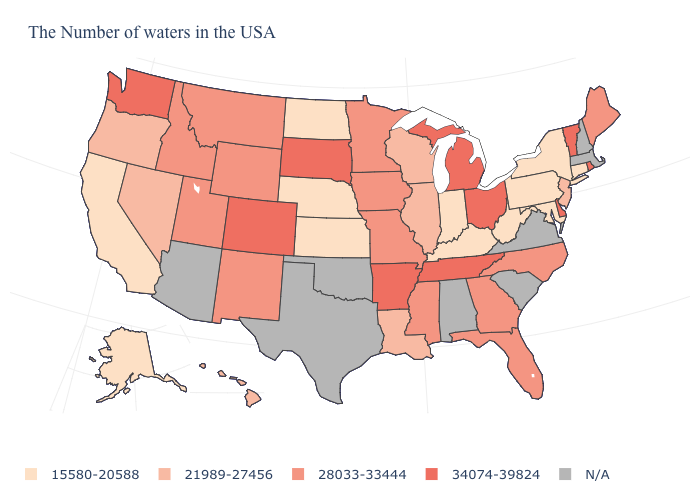Which states have the lowest value in the USA?
Write a very short answer. Connecticut, New York, Maryland, Pennsylvania, West Virginia, Kentucky, Indiana, Kansas, Nebraska, North Dakota, California, Alaska. Name the states that have a value in the range N/A?
Keep it brief. Massachusetts, New Hampshire, Virginia, South Carolina, Alabama, Oklahoma, Texas, Arizona. What is the value of Wyoming?
Concise answer only. 28033-33444. What is the value of Rhode Island?
Write a very short answer. 34074-39824. What is the highest value in the USA?
Keep it brief. 34074-39824. What is the highest value in the USA?
Concise answer only. 34074-39824. What is the value of Nevada?
Answer briefly. 21989-27456. What is the value of Arkansas?
Write a very short answer. 34074-39824. Is the legend a continuous bar?
Be succinct. No. What is the lowest value in states that border Rhode Island?
Keep it brief. 15580-20588. Name the states that have a value in the range N/A?
Concise answer only. Massachusetts, New Hampshire, Virginia, South Carolina, Alabama, Oklahoma, Texas, Arizona. Among the states that border Kentucky , which have the highest value?
Write a very short answer. Ohio, Tennessee. What is the value of Massachusetts?
Concise answer only. N/A. What is the lowest value in the South?
Short answer required. 15580-20588. 